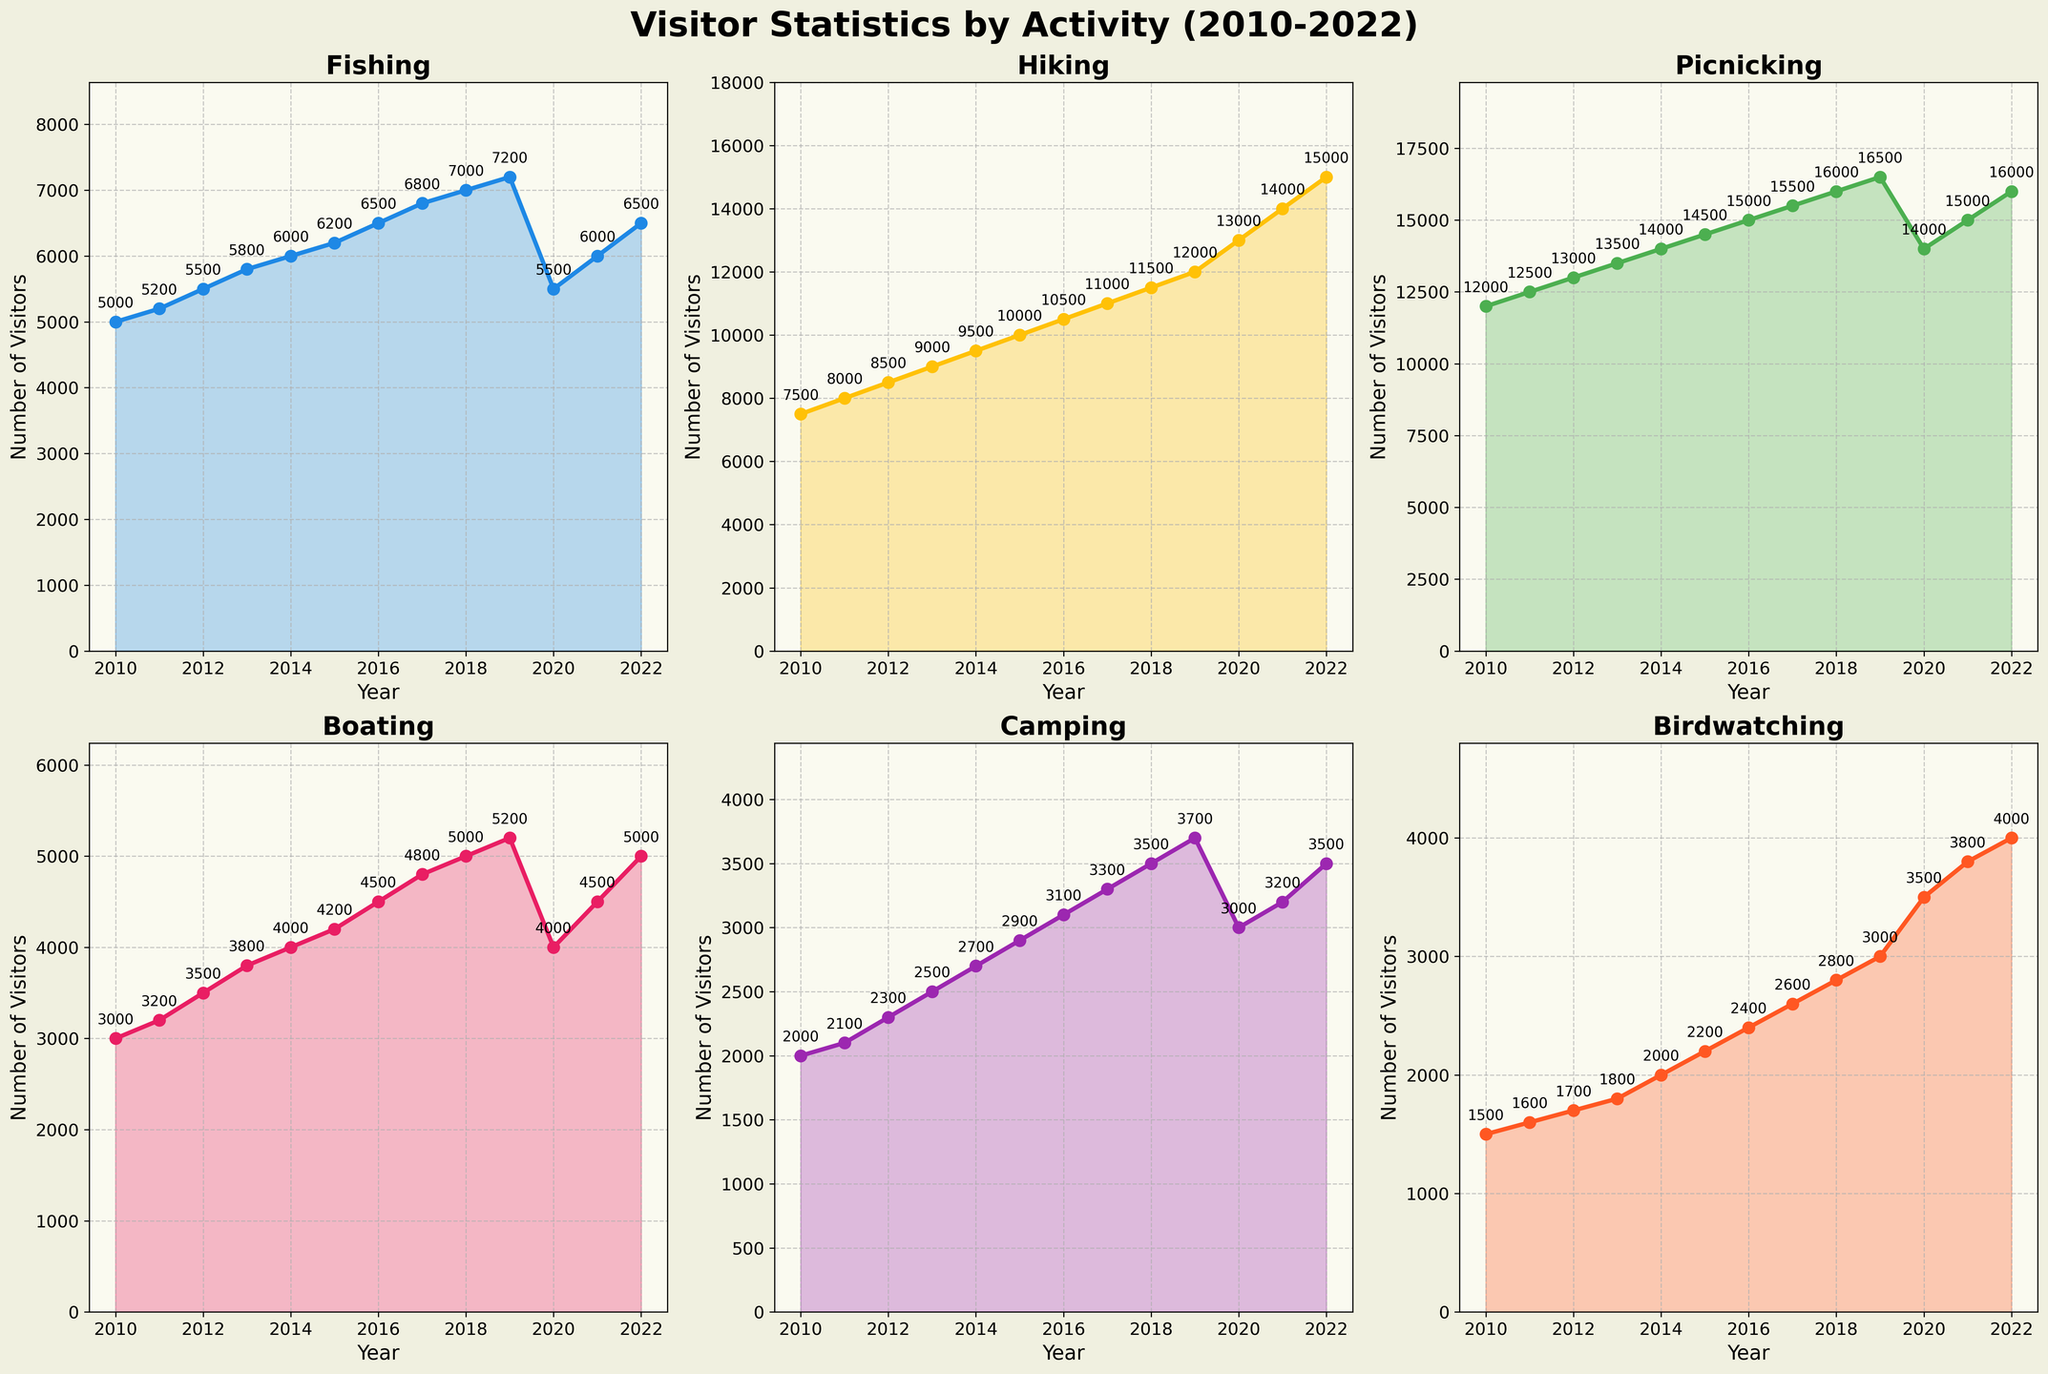Which activity had the highest number of visitors in 2014? To find this, look at the 2014 data points for all activities and identify which one is the highest. Picnicking is the activity with the highest number of visitors in 2014.
Answer: Picnicking What was the total number of visitors for all activities combined in 2012? Sum the number of visitors for all activities in 2012: 5500 (Fishing) + 8500 (Hiking) + 13000 (Picnicking) + 3500 (Boating) + 2300 (Camping) + 1700 (Birdwatching) = 34500.
Answer: 34500 Which activity showed the most significant decline in visitors from 2019 to 2020? Compare the visitor counts for each activity between 2019 and 2020, and identify the activity with the largest decrease. Fishing showed the most significant decline (7200 in 2019 to 5500 in 2020, which is a decrease of 1700).
Answer: Fishing Between 2010 and 2022, which activity had the most consistent increase in visitors? Look at the trend for each activity over the years and identify which one had a steady increase without major fluctuations. Hiking shows a steady and consistent increase.
Answer: Hiking What is the average number of visitors per year for Boating from 2010 to 2022? Sum the number of visitors for Boating over all years and divide by the number of years: (3000 + 3200 + 3500 + 3800 + 4000 + 4200 + 4500 + 4800 + 5000 + 5200 + 4000 + 4500 + 5000) / 13 = 4323.08.
Answer: 4323.08 How did Picnicking visitor numbers in 2020 compare to 2019? Compare the visitor counts for Picnicking between 2019 and 2020. In 2019, there were 16500 visitors, and in 2020, there were 14000, indicating a decrease.
Answer: Decreased What was the percentage increase in Birdwatching visitors from 2010 to 2022? Calculate the percentage increase using the formula [(Value in 2022 - Value in 2010) / Value in 2010] * 100. This gives [(4000 - 1500) / 1500] * 100 = 166.67%.
Answer: 166.67% Which two activities had an equal number of visitors in 2020? Examine the visitor data for 2020 to find any two activities with the same number of visitors. Fishing and Boating both had 4000 visitors in 2020.
Answer: Fishing and Boating Which activity had the least number of visitors every year from 2010 to 2022? Check the data for each activity across all years to see which one consistently has the lowest number of visitors. Birdwatching consistently had the least number of visitors.
Answer: Birdwatching 